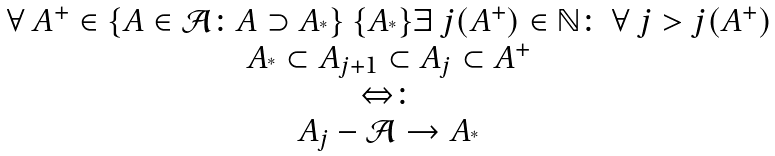<formula> <loc_0><loc_0><loc_500><loc_500>\begin{array} { c } \forall \ A ^ { + } \in \{ A \in \mathcal { A } \colon A \supset A _ { ^ { * } } \} \ \{ A _ { ^ { * } } \} \exists \ j ( A ^ { + } ) \in \mathbb { N } \colon \ \forall \ j > j ( A ^ { + } ) \\ A _ { ^ { * } } \subset A _ { j + 1 } \subset A _ { j } \subset A ^ { + } \\ \Leftrightarrow \colon \\ A _ { j } - \mathcal { A } \to A _ { ^ { * } } \end{array}</formula> 